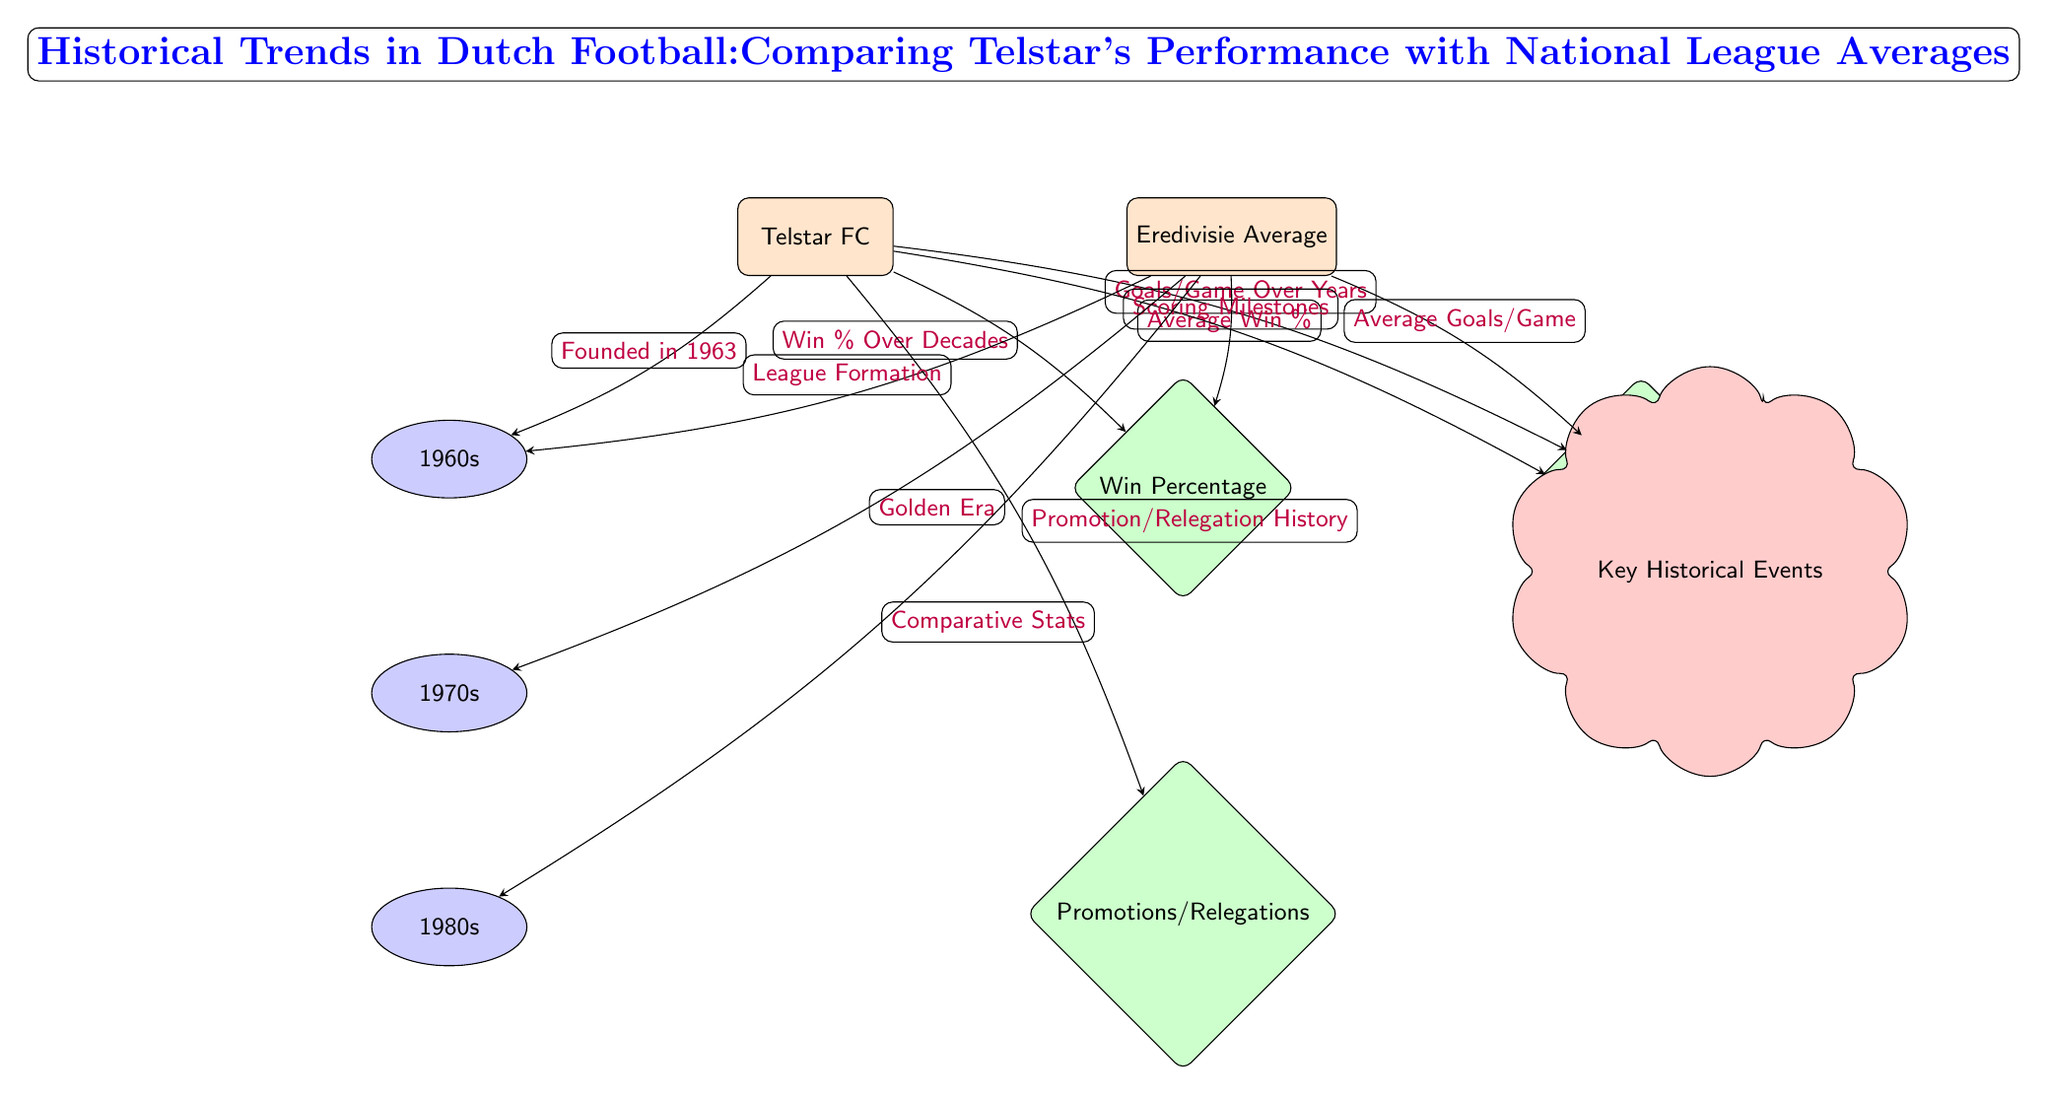What year was Telstar FC founded? The diagram indicates that Telstar FC was founded in 1963, as shown by the edge connecting the Telstar node to the period node for the 1960s, with the label stating "Founded in 1963."
Answer: 1963 What performance metric is associated with the nodes below Telstar? There are three performance metrics connected to Telstar: Win Percentage, Goals Per Game, and Promotions/Relegations. These are indicated by the performance nodes positioned below the Telstar node.
Answer: Win Percentage, Goals Per Game, Promotions/Relegations What significant event is related to the Eredivisie average in the 1970s? The diagram mentions a "Golden Era" associated with the Eredivisie average during the 1970s, indicated by an edge connecting Eredivisie Avg to the period node for the 1970s.
Answer: Golden Era How many periods are represented in the diagram? The diagram displays three distinct periods: the 1960s, 1970s, and 1980s, as shown by the period nodes below the respective entities.
Answer: 3 Which node describes Telstar's historical scoring achievements? The node that connects Telstar to key historical events, labeled "Scoring Milestones," describes Telstar's historical scoring achievements, which is positioned at the bottom right of the Telstar node.
Answer: Scoring Milestones What is the relationship between Telstar and the average goals per game? The diagram illustrates a relationship where Telstar's goals per game performance is compared to the average goals per game from the Eredivisie, indicated by an edge connecting Telstar to the performance node labeled Goals Per Game.
Answer: Goals Per Game What does the edge from Eredivisie Avg to PerformanceWins indicate? This edge indicates the average win percentage for the Eredivisie, connecting the Eredivisie Avg node to the PerformanceWins node, thus reflecting league-wide performance in wins.
Answer: Average Win Percentage What color represents the historical events in the diagram? The node representing historical events is colored red, which is evident from the fill color assigned to the event node connected to the Eredivisie Avg.
Answer: Red 